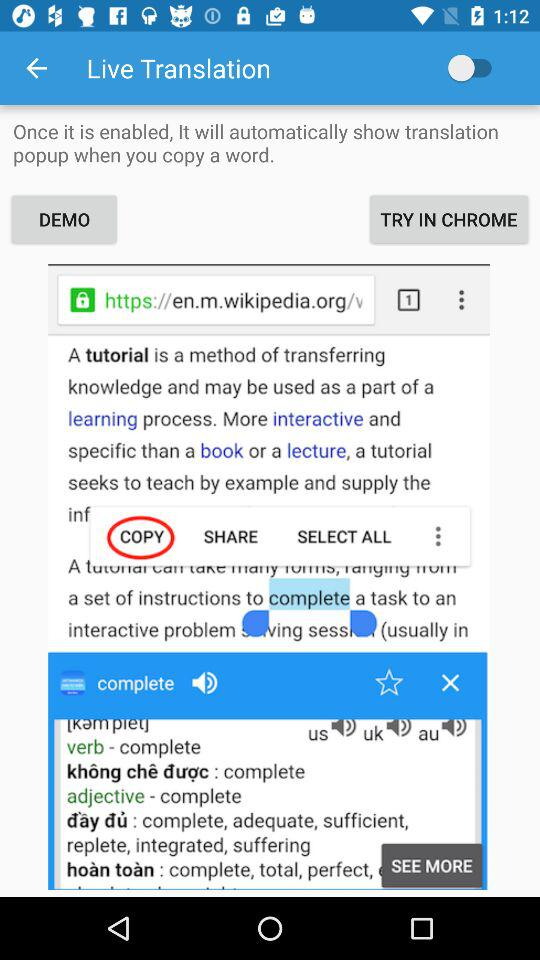What's the status of "Live Translation"? The status is "off". 